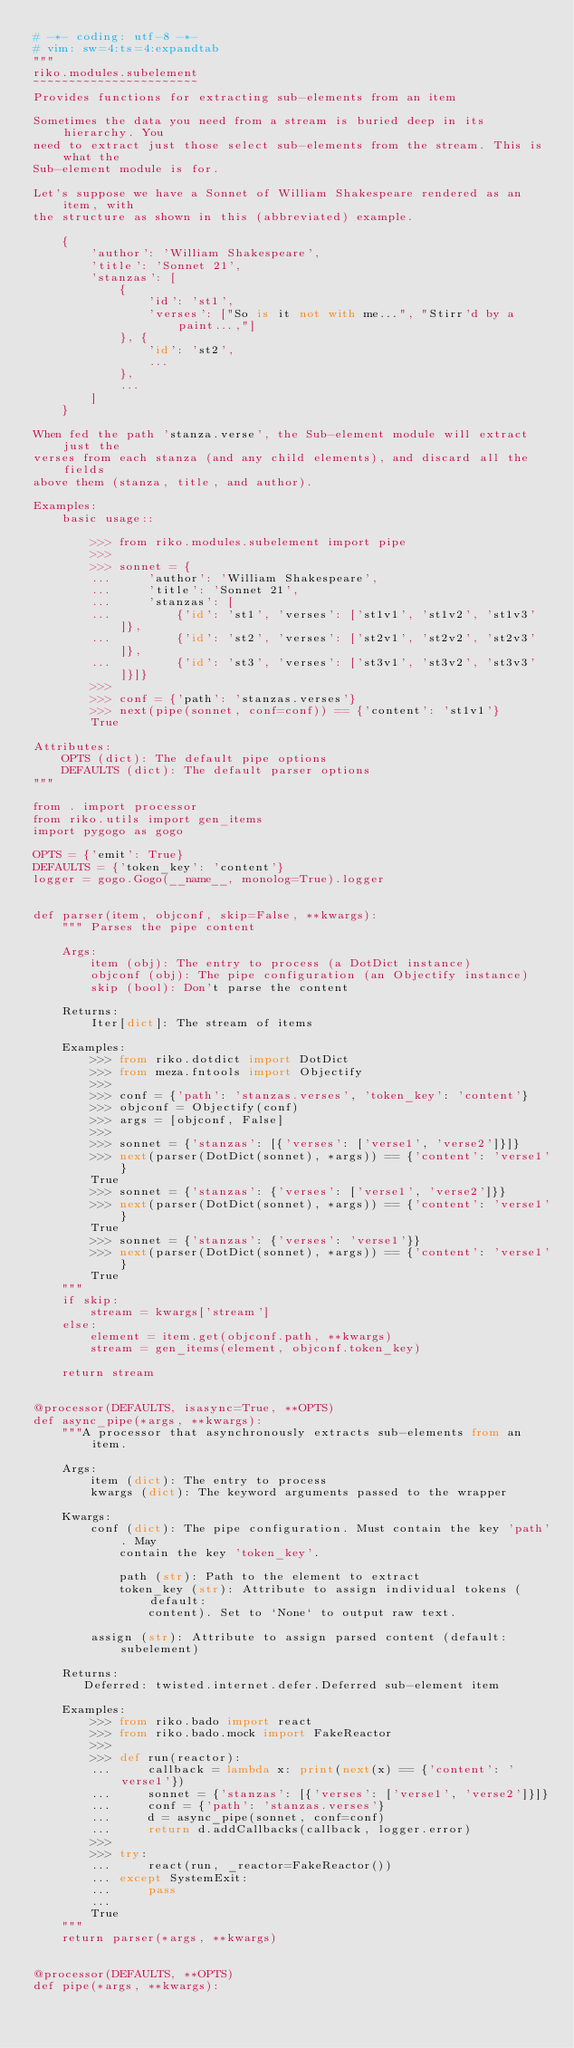<code> <loc_0><loc_0><loc_500><loc_500><_Python_># -*- coding: utf-8 -*-
# vim: sw=4:ts=4:expandtab
"""
riko.modules.subelement
~~~~~~~~~~~~~~~~~~~~~~~
Provides functions for extracting sub-elements from an item

Sometimes the data you need from a stream is buried deep in its hierarchy. You
need to extract just those select sub-elements from the stream. This is what the
Sub-element module is for.

Let's suppose we have a Sonnet of William Shakespeare rendered as an item, with
the structure as shown in this (abbreviated) example.

    {
        'author': 'William Shakespeare',
        'title': 'Sonnet 21',
        'stanzas': [
            {
                'id': 'st1',
                'verses': ["So is it not with me...", "Stirr'd by a paint...,"]
            }, {
                'id': 'st2',
                ...
            },
            ...
        ]
    }

When fed the path 'stanza.verse', the Sub-element module will extract just the
verses from each stanza (and any child elements), and discard all the fields
above them (stanza, title, and author).

Examples:
    basic usage::

        >>> from riko.modules.subelement import pipe
        >>>
        >>> sonnet = {
        ...     'author': 'William Shakespeare',
        ...     'title': 'Sonnet 21',
        ...     'stanzas': [
        ...         {'id': 'st1', 'verses': ['st1v1', 'st1v2', 'st1v3']},
        ...         {'id': 'st2', 'verses': ['st2v1', 'st2v2', 'st2v3']},
        ...         {'id': 'st3', 'verses': ['st3v1', 'st3v2', 'st3v3']}]}
        >>>
        >>> conf = {'path': 'stanzas.verses'}
        >>> next(pipe(sonnet, conf=conf)) == {'content': 'st1v1'}
        True

Attributes:
    OPTS (dict): The default pipe options
    DEFAULTS (dict): The default parser options
"""

from . import processor
from riko.utils import gen_items
import pygogo as gogo

OPTS = {'emit': True}
DEFAULTS = {'token_key': 'content'}
logger = gogo.Gogo(__name__, monolog=True).logger


def parser(item, objconf, skip=False, **kwargs):
    """ Parses the pipe content

    Args:
        item (obj): The entry to process (a DotDict instance)
        objconf (obj): The pipe configuration (an Objectify instance)
        skip (bool): Don't parse the content

    Returns:
        Iter[dict]: The stream of items

    Examples:
        >>> from riko.dotdict import DotDict
        >>> from meza.fntools import Objectify
        >>>
        >>> conf = {'path': 'stanzas.verses', 'token_key': 'content'}
        >>> objconf = Objectify(conf)
        >>> args = [objconf, False]
        >>>
        >>> sonnet = {'stanzas': [{'verses': ['verse1', 'verse2']}]}
        >>> next(parser(DotDict(sonnet), *args)) == {'content': 'verse1'}
        True
        >>> sonnet = {'stanzas': {'verses': ['verse1', 'verse2']}}
        >>> next(parser(DotDict(sonnet), *args)) == {'content': 'verse1'}
        True
        >>> sonnet = {'stanzas': {'verses': 'verse1'}}
        >>> next(parser(DotDict(sonnet), *args)) == {'content': 'verse1'}
        True
    """
    if skip:
        stream = kwargs['stream']
    else:
        element = item.get(objconf.path, **kwargs)
        stream = gen_items(element, objconf.token_key)

    return stream


@processor(DEFAULTS, isasync=True, **OPTS)
def async_pipe(*args, **kwargs):
    """A processor that asynchronously extracts sub-elements from an item.

    Args:
        item (dict): The entry to process
        kwargs (dict): The keyword arguments passed to the wrapper

    Kwargs:
        conf (dict): The pipe configuration. Must contain the key 'path'. May
            contain the key 'token_key'.

            path (str): Path to the element to extract
            token_key (str): Attribute to assign individual tokens (default:
                content). Set to `None` to output raw text.

        assign (str): Attribute to assign parsed content (default: subelement)

    Returns:
       Deferred: twisted.internet.defer.Deferred sub-element item

    Examples:
        >>> from riko.bado import react
        >>> from riko.bado.mock import FakeReactor
        >>>
        >>> def run(reactor):
        ...     callback = lambda x: print(next(x) == {'content': 'verse1'})
        ...     sonnet = {'stanzas': [{'verses': ['verse1', 'verse2']}]}
        ...     conf = {'path': 'stanzas.verses'}
        ...     d = async_pipe(sonnet, conf=conf)
        ...     return d.addCallbacks(callback, logger.error)
        >>>
        >>> try:
        ...     react(run, _reactor=FakeReactor())
        ... except SystemExit:
        ...     pass
        ...
        True
    """
    return parser(*args, **kwargs)


@processor(DEFAULTS, **OPTS)
def pipe(*args, **kwargs):</code> 